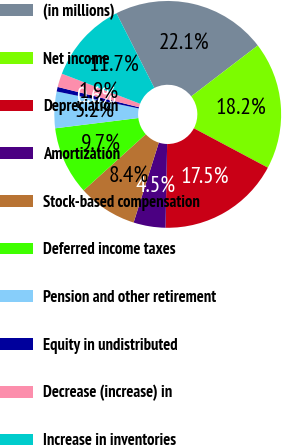Convert chart to OTSL. <chart><loc_0><loc_0><loc_500><loc_500><pie_chart><fcel>(in millions)<fcel>Net income<fcel>Depreciation<fcel>Amortization<fcel>Stock-based compensation<fcel>Deferred income taxes<fcel>Pension and other retirement<fcel>Equity in undistributed<fcel>Decrease (increase) in<fcel>Increase in inventories<nl><fcel>22.08%<fcel>18.18%<fcel>17.53%<fcel>4.55%<fcel>8.44%<fcel>9.74%<fcel>5.2%<fcel>0.65%<fcel>1.95%<fcel>11.69%<nl></chart> 